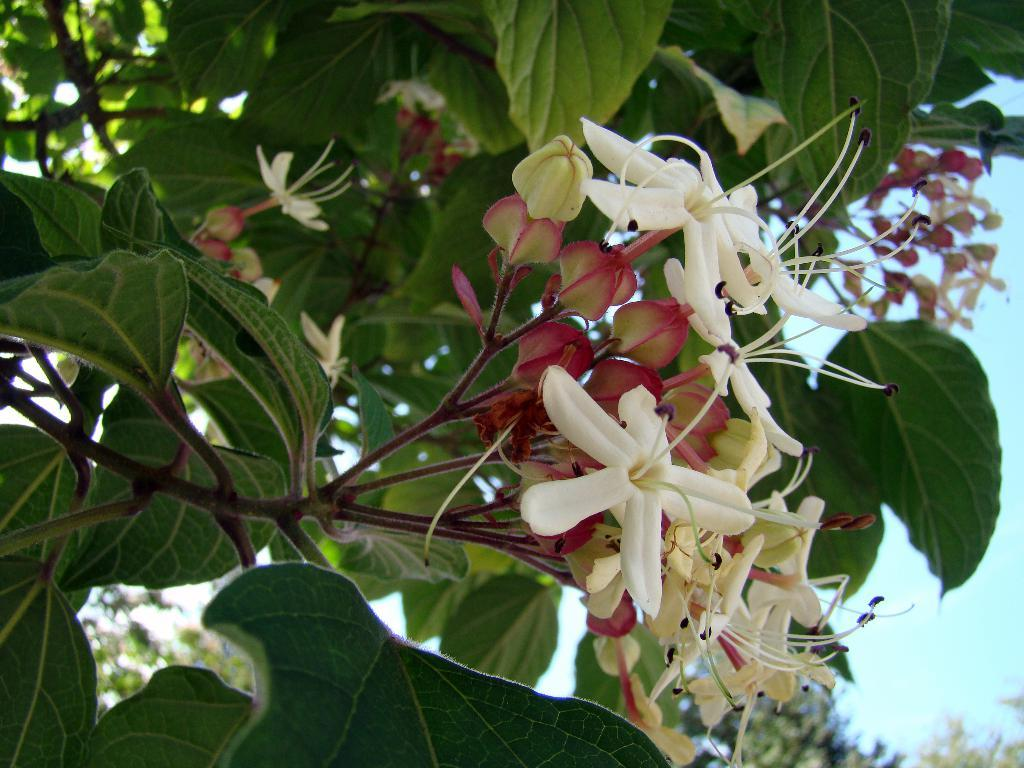What colors are the flowers on the tree in the image? The flowers on the tree are white and red. What stage of growth are the flowers on the tree in? There are flower buds on the tree, indicating that they are in the early stages of growth. What can be seen in the background of the image? There are trees and the sky visible in the background of the image. Can you see a goat climbing the tree in the image? No, there is no goat present in the image. What angle is the bat hanging from the tree in the image? There is no bat present in the image. 